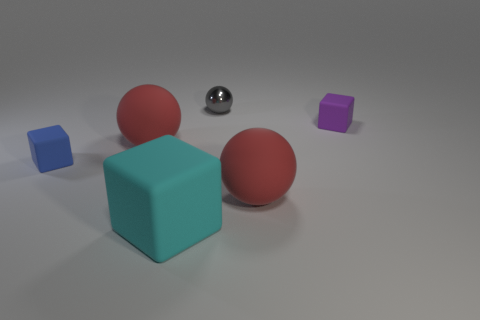Which objects in this image appear to have a glossy finish? The sphere in the center has a glossy finish, reflecting the light and its surroundings with a clear, mirror-like quality. 